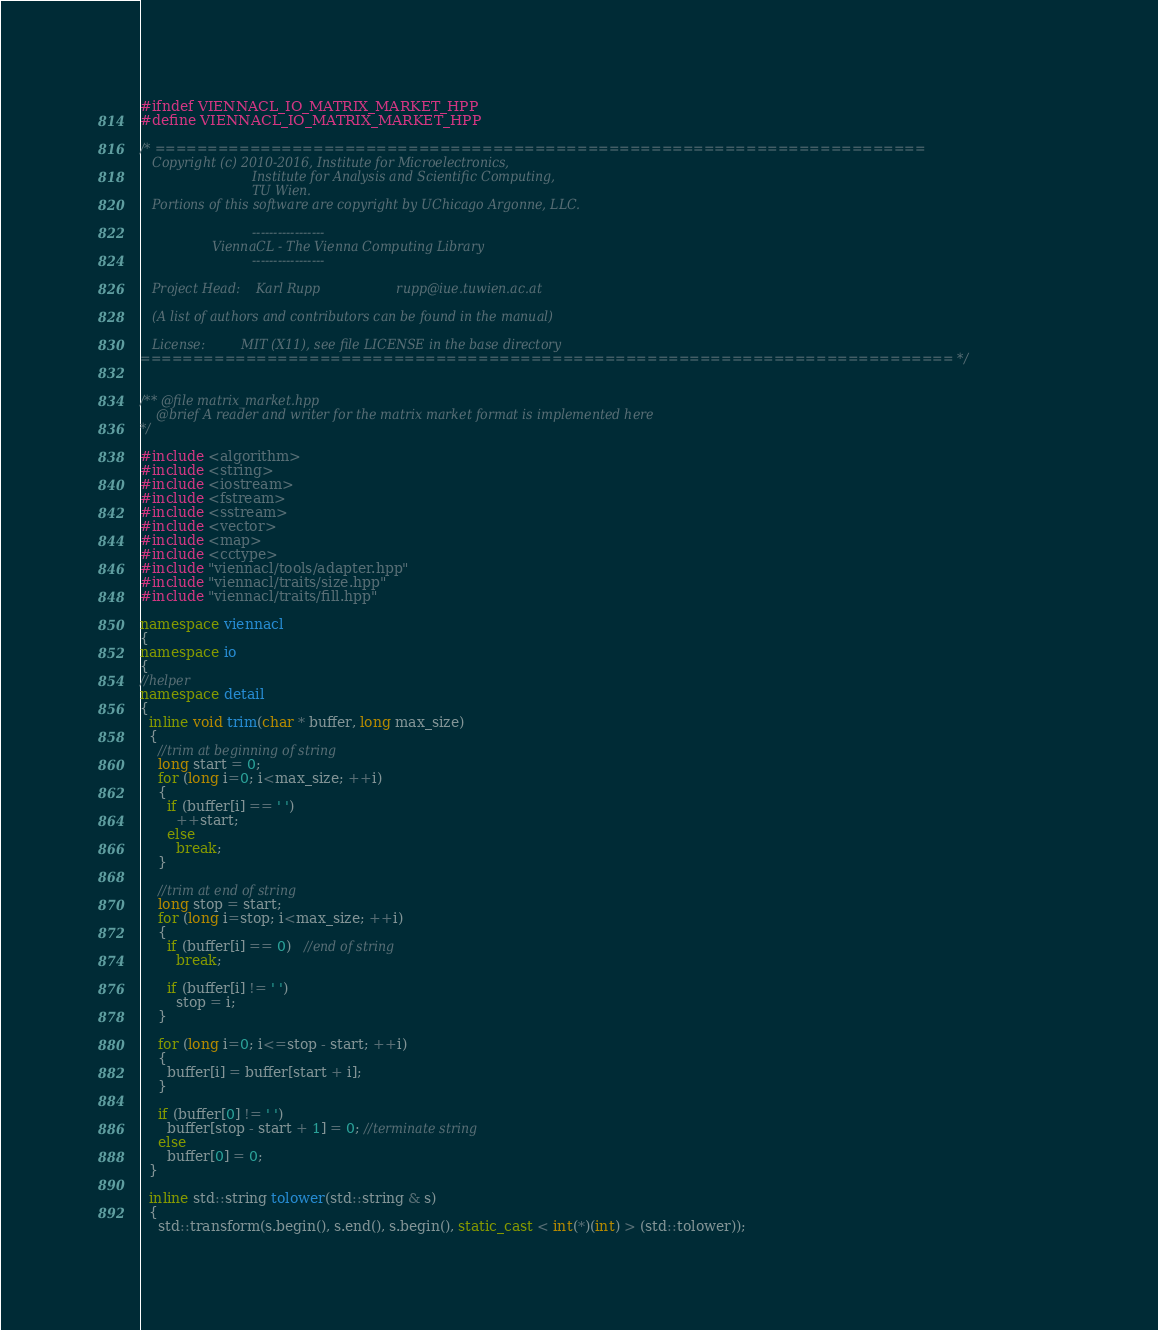<code> <loc_0><loc_0><loc_500><loc_500><_C++_>#ifndef VIENNACL_IO_MATRIX_MARKET_HPP
#define VIENNACL_IO_MATRIX_MARKET_HPP

/* =========================================================================
   Copyright (c) 2010-2016, Institute for Microelectronics,
                            Institute for Analysis and Scientific Computing,
                            TU Wien.
   Portions of this software are copyright by UChicago Argonne, LLC.

                            -----------------
                  ViennaCL - The Vienna Computing Library
                            -----------------

   Project Head:    Karl Rupp                   rupp@iue.tuwien.ac.at

   (A list of authors and contributors can be found in the manual)

   License:         MIT (X11), see file LICENSE in the base directory
============================================================================= */


/** @file matrix_market.hpp
    @brief A reader and writer for the matrix market format is implemented here
*/

#include <algorithm>
#include <string>
#include <iostream>
#include <fstream>
#include <sstream>
#include <vector>
#include <map>
#include <cctype>
#include "viennacl/tools/adapter.hpp"
#include "viennacl/traits/size.hpp"
#include "viennacl/traits/fill.hpp"

namespace viennacl
{
namespace io
{
//helper
namespace detail
{
  inline void trim(char * buffer, long max_size)
  {
    //trim at beginning of string
    long start = 0;
    for (long i=0; i<max_size; ++i)
    {
      if (buffer[i] == ' ')
        ++start;
      else
        break;
    }

    //trim at end of string
    long stop = start;
    for (long i=stop; i<max_size; ++i)
    {
      if (buffer[i] == 0)   //end of string
        break;

      if (buffer[i] != ' ')
        stop = i;
    }

    for (long i=0; i<=stop - start; ++i)
    {
      buffer[i] = buffer[start + i];
    }

    if (buffer[0] != ' ')
      buffer[stop - start + 1] = 0; //terminate string
    else
      buffer[0] = 0;
  }

  inline std::string tolower(std::string & s)
  {
    std::transform(s.begin(), s.end(), s.begin(), static_cast < int(*)(int) > (std::tolower));</code> 